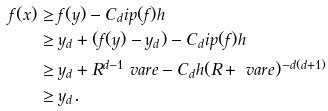<formula> <loc_0><loc_0><loc_500><loc_500>f ( x ) & \geq f ( y ) - C _ { d } \L i p ( f ) h \\ & \geq y _ { d } + ( f ( y ) - y _ { d } ) - C _ { d } \L i p ( f ) h \\ & \geq y _ { d } + R ^ { d - 1 } \ v a r e - C _ { d } h ( R + \ v a r e ) ^ { - d ( d + 1 ) } \\ & \geq y _ { d } .</formula> 